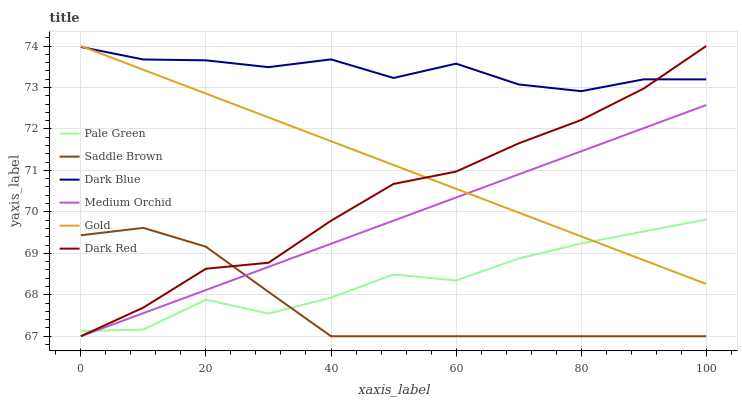Does Saddle Brown have the minimum area under the curve?
Answer yes or no. Yes. Does Dark Blue have the maximum area under the curve?
Answer yes or no. Yes. Does Dark Red have the minimum area under the curve?
Answer yes or no. No. Does Dark Red have the maximum area under the curve?
Answer yes or no. No. Is Gold the smoothest?
Answer yes or no. Yes. Is Pale Green the roughest?
Answer yes or no. Yes. Is Dark Red the smoothest?
Answer yes or no. No. Is Dark Red the roughest?
Answer yes or no. No. Does Dark Red have the lowest value?
Answer yes or no. Yes. Does Dark Blue have the lowest value?
Answer yes or no. No. Does Dark Red have the highest value?
Answer yes or no. Yes. Does Medium Orchid have the highest value?
Answer yes or no. No. Is Saddle Brown less than Dark Blue?
Answer yes or no. Yes. Is Dark Blue greater than Pale Green?
Answer yes or no. Yes. Does Medium Orchid intersect Saddle Brown?
Answer yes or no. Yes. Is Medium Orchid less than Saddle Brown?
Answer yes or no. No. Is Medium Orchid greater than Saddle Brown?
Answer yes or no. No. Does Saddle Brown intersect Dark Blue?
Answer yes or no. No. 